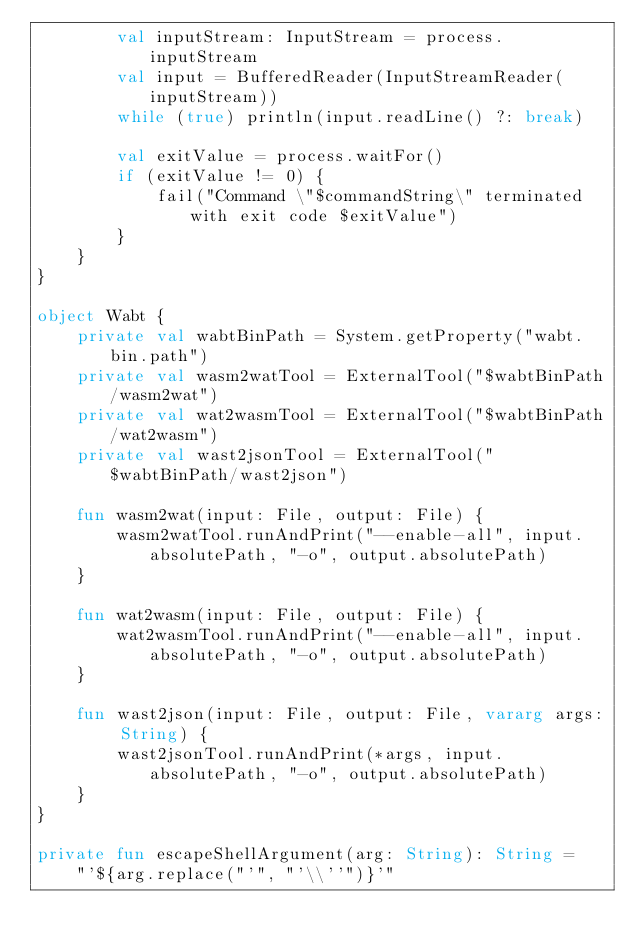<code> <loc_0><loc_0><loc_500><loc_500><_Kotlin_>        val inputStream: InputStream = process.inputStream
        val input = BufferedReader(InputStreamReader(inputStream))
        while (true) println(input.readLine() ?: break)

        val exitValue = process.waitFor()
        if (exitValue != 0) {
            fail("Command \"$commandString\" terminated with exit code $exitValue")
        }
    }
}

object Wabt {
    private val wabtBinPath = System.getProperty("wabt.bin.path")
    private val wasm2watTool = ExternalTool("$wabtBinPath/wasm2wat")
    private val wat2wasmTool = ExternalTool("$wabtBinPath/wat2wasm")
    private val wast2jsonTool = ExternalTool("$wabtBinPath/wast2json")

    fun wasm2wat(input: File, output: File) {
        wasm2watTool.runAndPrint("--enable-all", input.absolutePath, "-o", output.absolutePath)
    }

    fun wat2wasm(input: File, output: File) {
        wat2wasmTool.runAndPrint("--enable-all", input.absolutePath, "-o", output.absolutePath)
    }

    fun wast2json(input: File, output: File, vararg args: String) {
        wast2jsonTool.runAndPrint(*args, input.absolutePath, "-o", output.absolutePath)
    }
}

private fun escapeShellArgument(arg: String): String =
    "'${arg.replace("'", "'\\''")}'"
</code> 